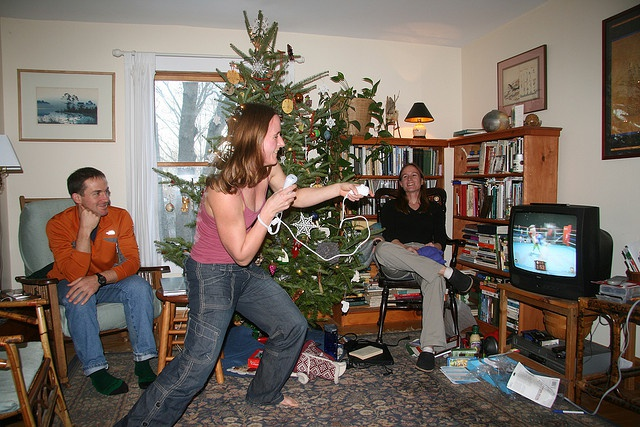Describe the objects in this image and their specific colors. I can see people in gray, black, lightpink, and brown tones, people in gray, brown, black, and blue tones, tv in gray, black, and lightblue tones, people in gray and black tones, and chair in gray, black, and maroon tones in this image. 